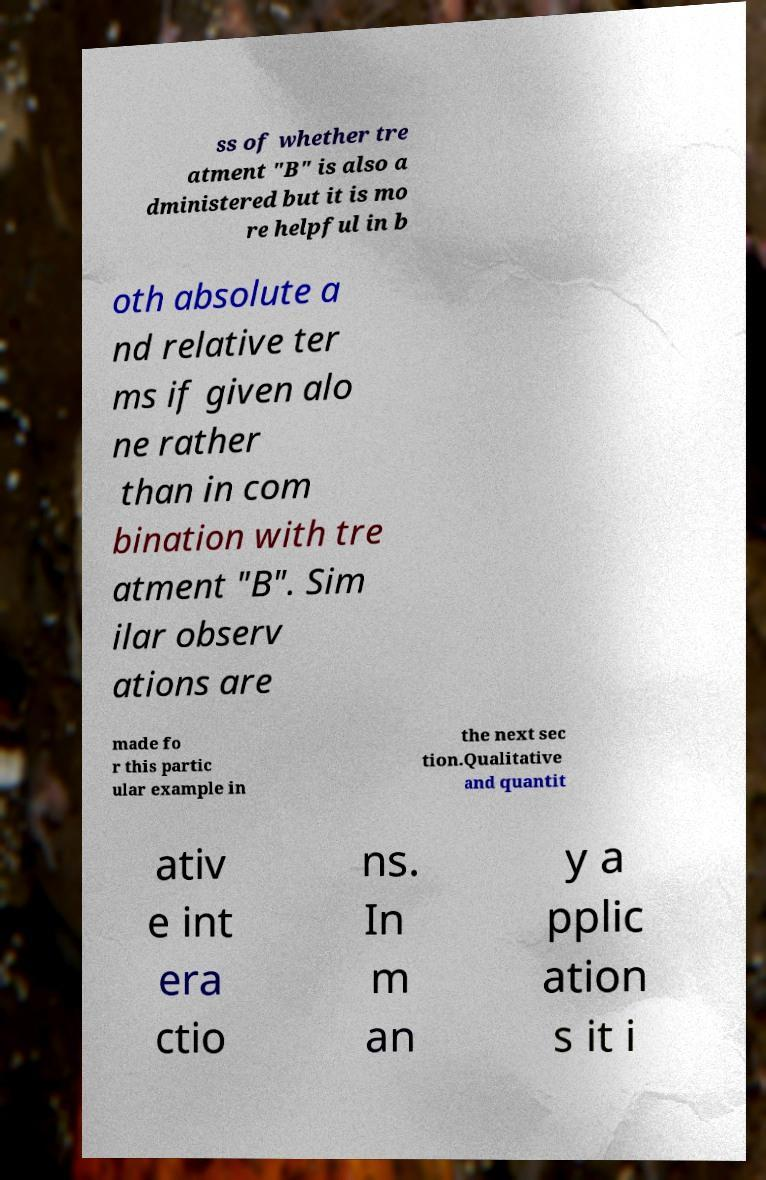Please identify and transcribe the text found in this image. ss of whether tre atment "B" is also a dministered but it is mo re helpful in b oth absolute a nd relative ter ms if given alo ne rather than in com bination with tre atment "B". Sim ilar observ ations are made fo r this partic ular example in the next sec tion.Qualitative and quantit ativ e int era ctio ns. In m an y a pplic ation s it i 